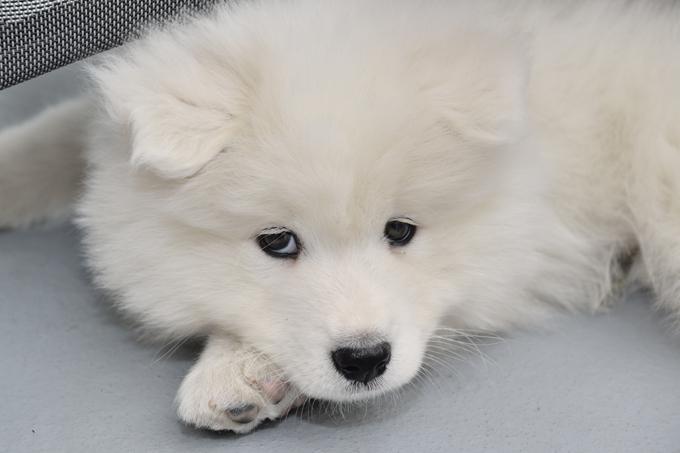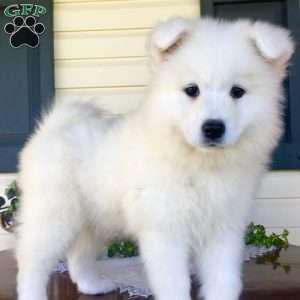The first image is the image on the left, the second image is the image on the right. Examine the images to the left and right. Is the description "The left image contains at least two white dogs." accurate? Answer yes or no. No. The first image is the image on the left, the second image is the image on the right. Analyze the images presented: Is the assertion "There are four dogs." valid? Answer yes or no. No. The first image is the image on the left, the second image is the image on the right. For the images shown, is this caption "Each image contains exactly one white dog, and one of the dogs is standing on all fours." true? Answer yes or no. Yes. 